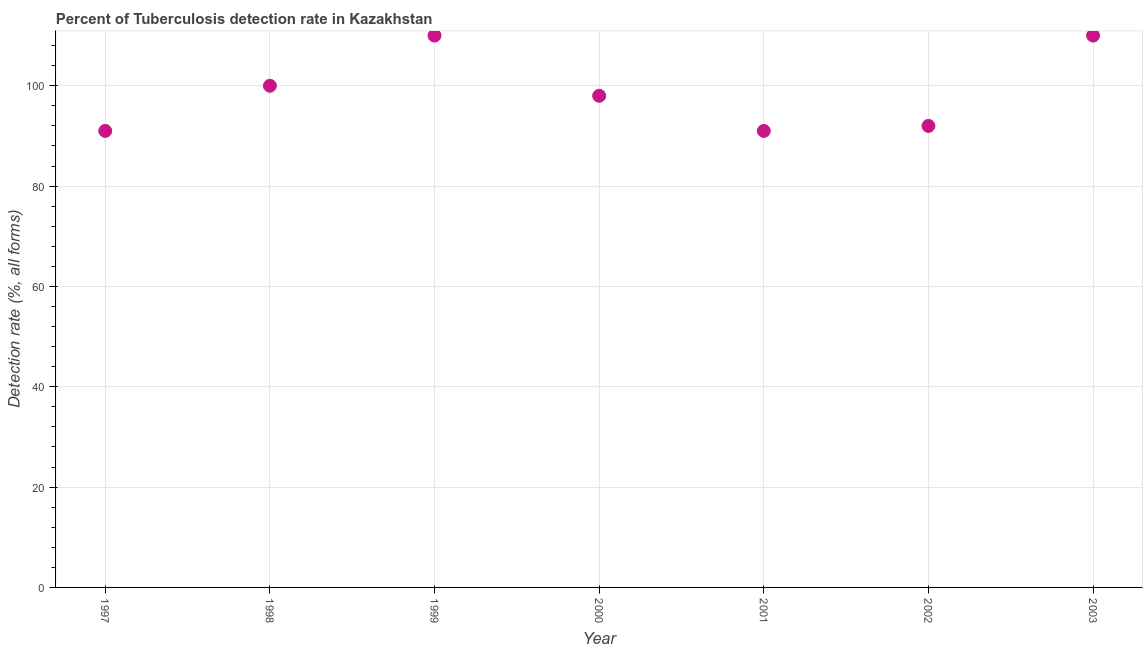What is the detection rate of tuberculosis in 2001?
Keep it short and to the point. 91. Across all years, what is the maximum detection rate of tuberculosis?
Offer a terse response. 110. Across all years, what is the minimum detection rate of tuberculosis?
Your answer should be compact. 91. What is the sum of the detection rate of tuberculosis?
Ensure brevity in your answer.  692. What is the difference between the detection rate of tuberculosis in 2000 and 2001?
Provide a succinct answer. 7. What is the average detection rate of tuberculosis per year?
Keep it short and to the point. 98.86. Do a majority of the years between 1998 and 2003 (inclusive) have detection rate of tuberculosis greater than 48 %?
Your answer should be compact. Yes. What is the ratio of the detection rate of tuberculosis in 2001 to that in 2002?
Keep it short and to the point. 0.99. What is the difference between the highest and the lowest detection rate of tuberculosis?
Offer a very short reply. 19. In how many years, is the detection rate of tuberculosis greater than the average detection rate of tuberculosis taken over all years?
Provide a short and direct response. 3. How many years are there in the graph?
Provide a succinct answer. 7. What is the difference between two consecutive major ticks on the Y-axis?
Provide a short and direct response. 20. Are the values on the major ticks of Y-axis written in scientific E-notation?
Make the answer very short. No. What is the title of the graph?
Give a very brief answer. Percent of Tuberculosis detection rate in Kazakhstan. What is the label or title of the X-axis?
Make the answer very short. Year. What is the label or title of the Y-axis?
Your response must be concise. Detection rate (%, all forms). What is the Detection rate (%, all forms) in 1997?
Your response must be concise. 91. What is the Detection rate (%, all forms) in 1998?
Keep it short and to the point. 100. What is the Detection rate (%, all forms) in 1999?
Your answer should be very brief. 110. What is the Detection rate (%, all forms) in 2000?
Your response must be concise. 98. What is the Detection rate (%, all forms) in 2001?
Your answer should be compact. 91. What is the Detection rate (%, all forms) in 2002?
Offer a very short reply. 92. What is the Detection rate (%, all forms) in 2003?
Your answer should be compact. 110. What is the difference between the Detection rate (%, all forms) in 1998 and 1999?
Your answer should be very brief. -10. What is the difference between the Detection rate (%, all forms) in 1998 and 2000?
Make the answer very short. 2. What is the difference between the Detection rate (%, all forms) in 1998 and 2002?
Provide a short and direct response. 8. What is the difference between the Detection rate (%, all forms) in 1998 and 2003?
Give a very brief answer. -10. What is the difference between the Detection rate (%, all forms) in 1999 and 2000?
Your response must be concise. 12. What is the difference between the Detection rate (%, all forms) in 1999 and 2002?
Your answer should be compact. 18. What is the difference between the Detection rate (%, all forms) in 1999 and 2003?
Make the answer very short. 0. What is the difference between the Detection rate (%, all forms) in 2000 and 2001?
Give a very brief answer. 7. What is the difference between the Detection rate (%, all forms) in 2001 and 2002?
Give a very brief answer. -1. What is the difference between the Detection rate (%, all forms) in 2001 and 2003?
Give a very brief answer. -19. What is the difference between the Detection rate (%, all forms) in 2002 and 2003?
Offer a terse response. -18. What is the ratio of the Detection rate (%, all forms) in 1997 to that in 1998?
Ensure brevity in your answer.  0.91. What is the ratio of the Detection rate (%, all forms) in 1997 to that in 1999?
Keep it short and to the point. 0.83. What is the ratio of the Detection rate (%, all forms) in 1997 to that in 2000?
Your answer should be compact. 0.93. What is the ratio of the Detection rate (%, all forms) in 1997 to that in 2002?
Provide a succinct answer. 0.99. What is the ratio of the Detection rate (%, all forms) in 1997 to that in 2003?
Your answer should be very brief. 0.83. What is the ratio of the Detection rate (%, all forms) in 1998 to that in 1999?
Offer a terse response. 0.91. What is the ratio of the Detection rate (%, all forms) in 1998 to that in 2000?
Provide a succinct answer. 1.02. What is the ratio of the Detection rate (%, all forms) in 1998 to that in 2001?
Your response must be concise. 1.1. What is the ratio of the Detection rate (%, all forms) in 1998 to that in 2002?
Make the answer very short. 1.09. What is the ratio of the Detection rate (%, all forms) in 1998 to that in 2003?
Keep it short and to the point. 0.91. What is the ratio of the Detection rate (%, all forms) in 1999 to that in 2000?
Make the answer very short. 1.12. What is the ratio of the Detection rate (%, all forms) in 1999 to that in 2001?
Give a very brief answer. 1.21. What is the ratio of the Detection rate (%, all forms) in 1999 to that in 2002?
Your answer should be compact. 1.2. What is the ratio of the Detection rate (%, all forms) in 2000 to that in 2001?
Offer a very short reply. 1.08. What is the ratio of the Detection rate (%, all forms) in 2000 to that in 2002?
Give a very brief answer. 1.06. What is the ratio of the Detection rate (%, all forms) in 2000 to that in 2003?
Provide a succinct answer. 0.89. What is the ratio of the Detection rate (%, all forms) in 2001 to that in 2003?
Offer a very short reply. 0.83. What is the ratio of the Detection rate (%, all forms) in 2002 to that in 2003?
Offer a terse response. 0.84. 